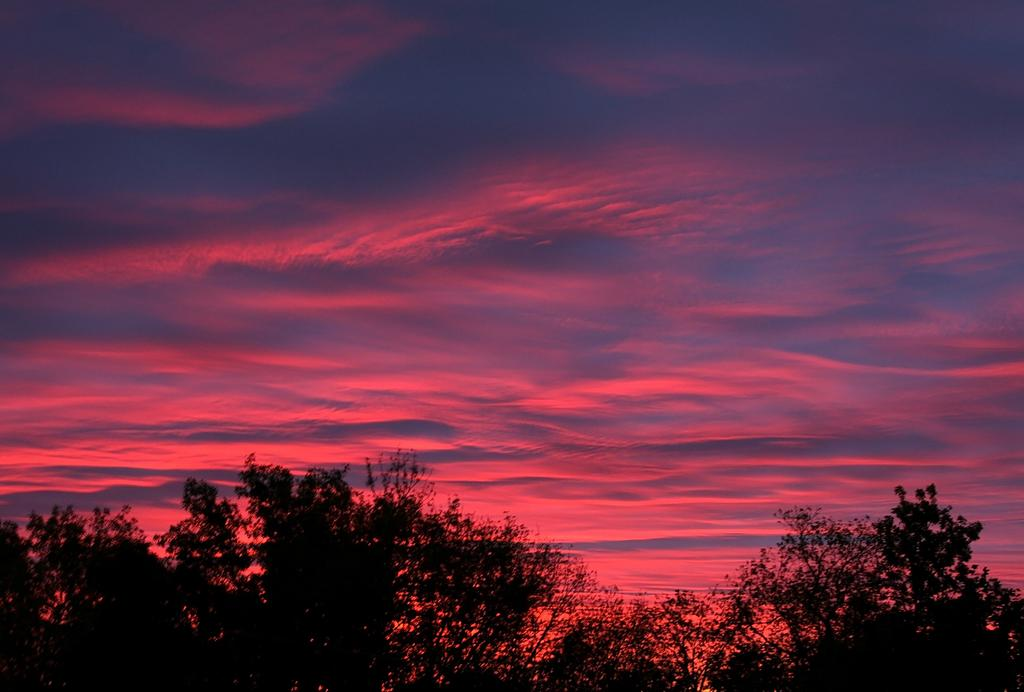What type of vegetation can be seen in the image? There are trees in the image. What is visible in the background of the image? The sky is visible in the image. What can be observed in the sky? Clouds are present in the sky. What type of tin can be seen on the page in the image? There is no tin or page present in the image; it only features trees and clouds in the sky. 